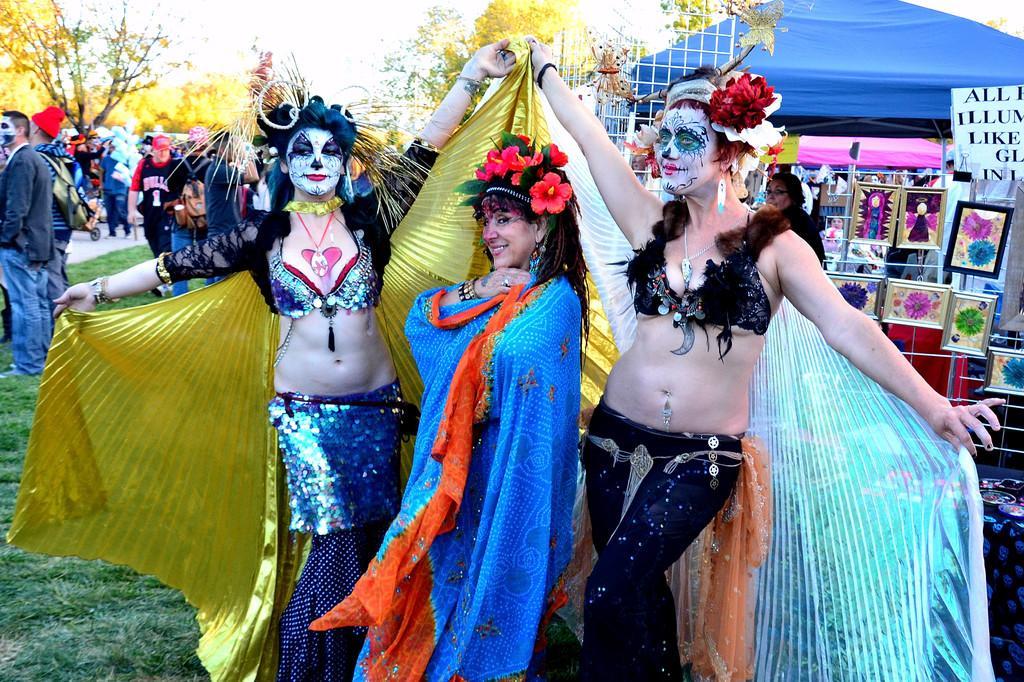Describe this image in one or two sentences. In this image we can see some group of persons wearing different costumes standing and in the background of the image there are some stores under tents, there are some trees and clear sky. 